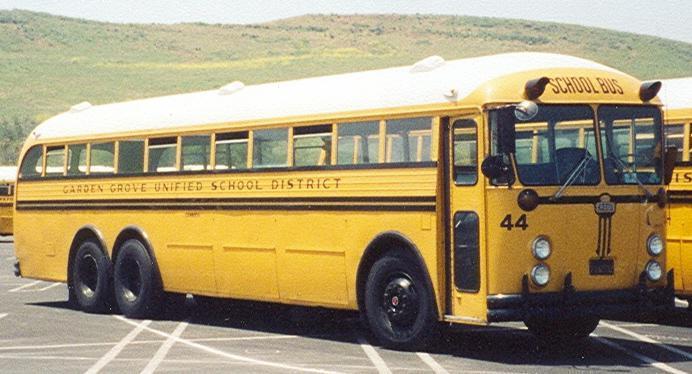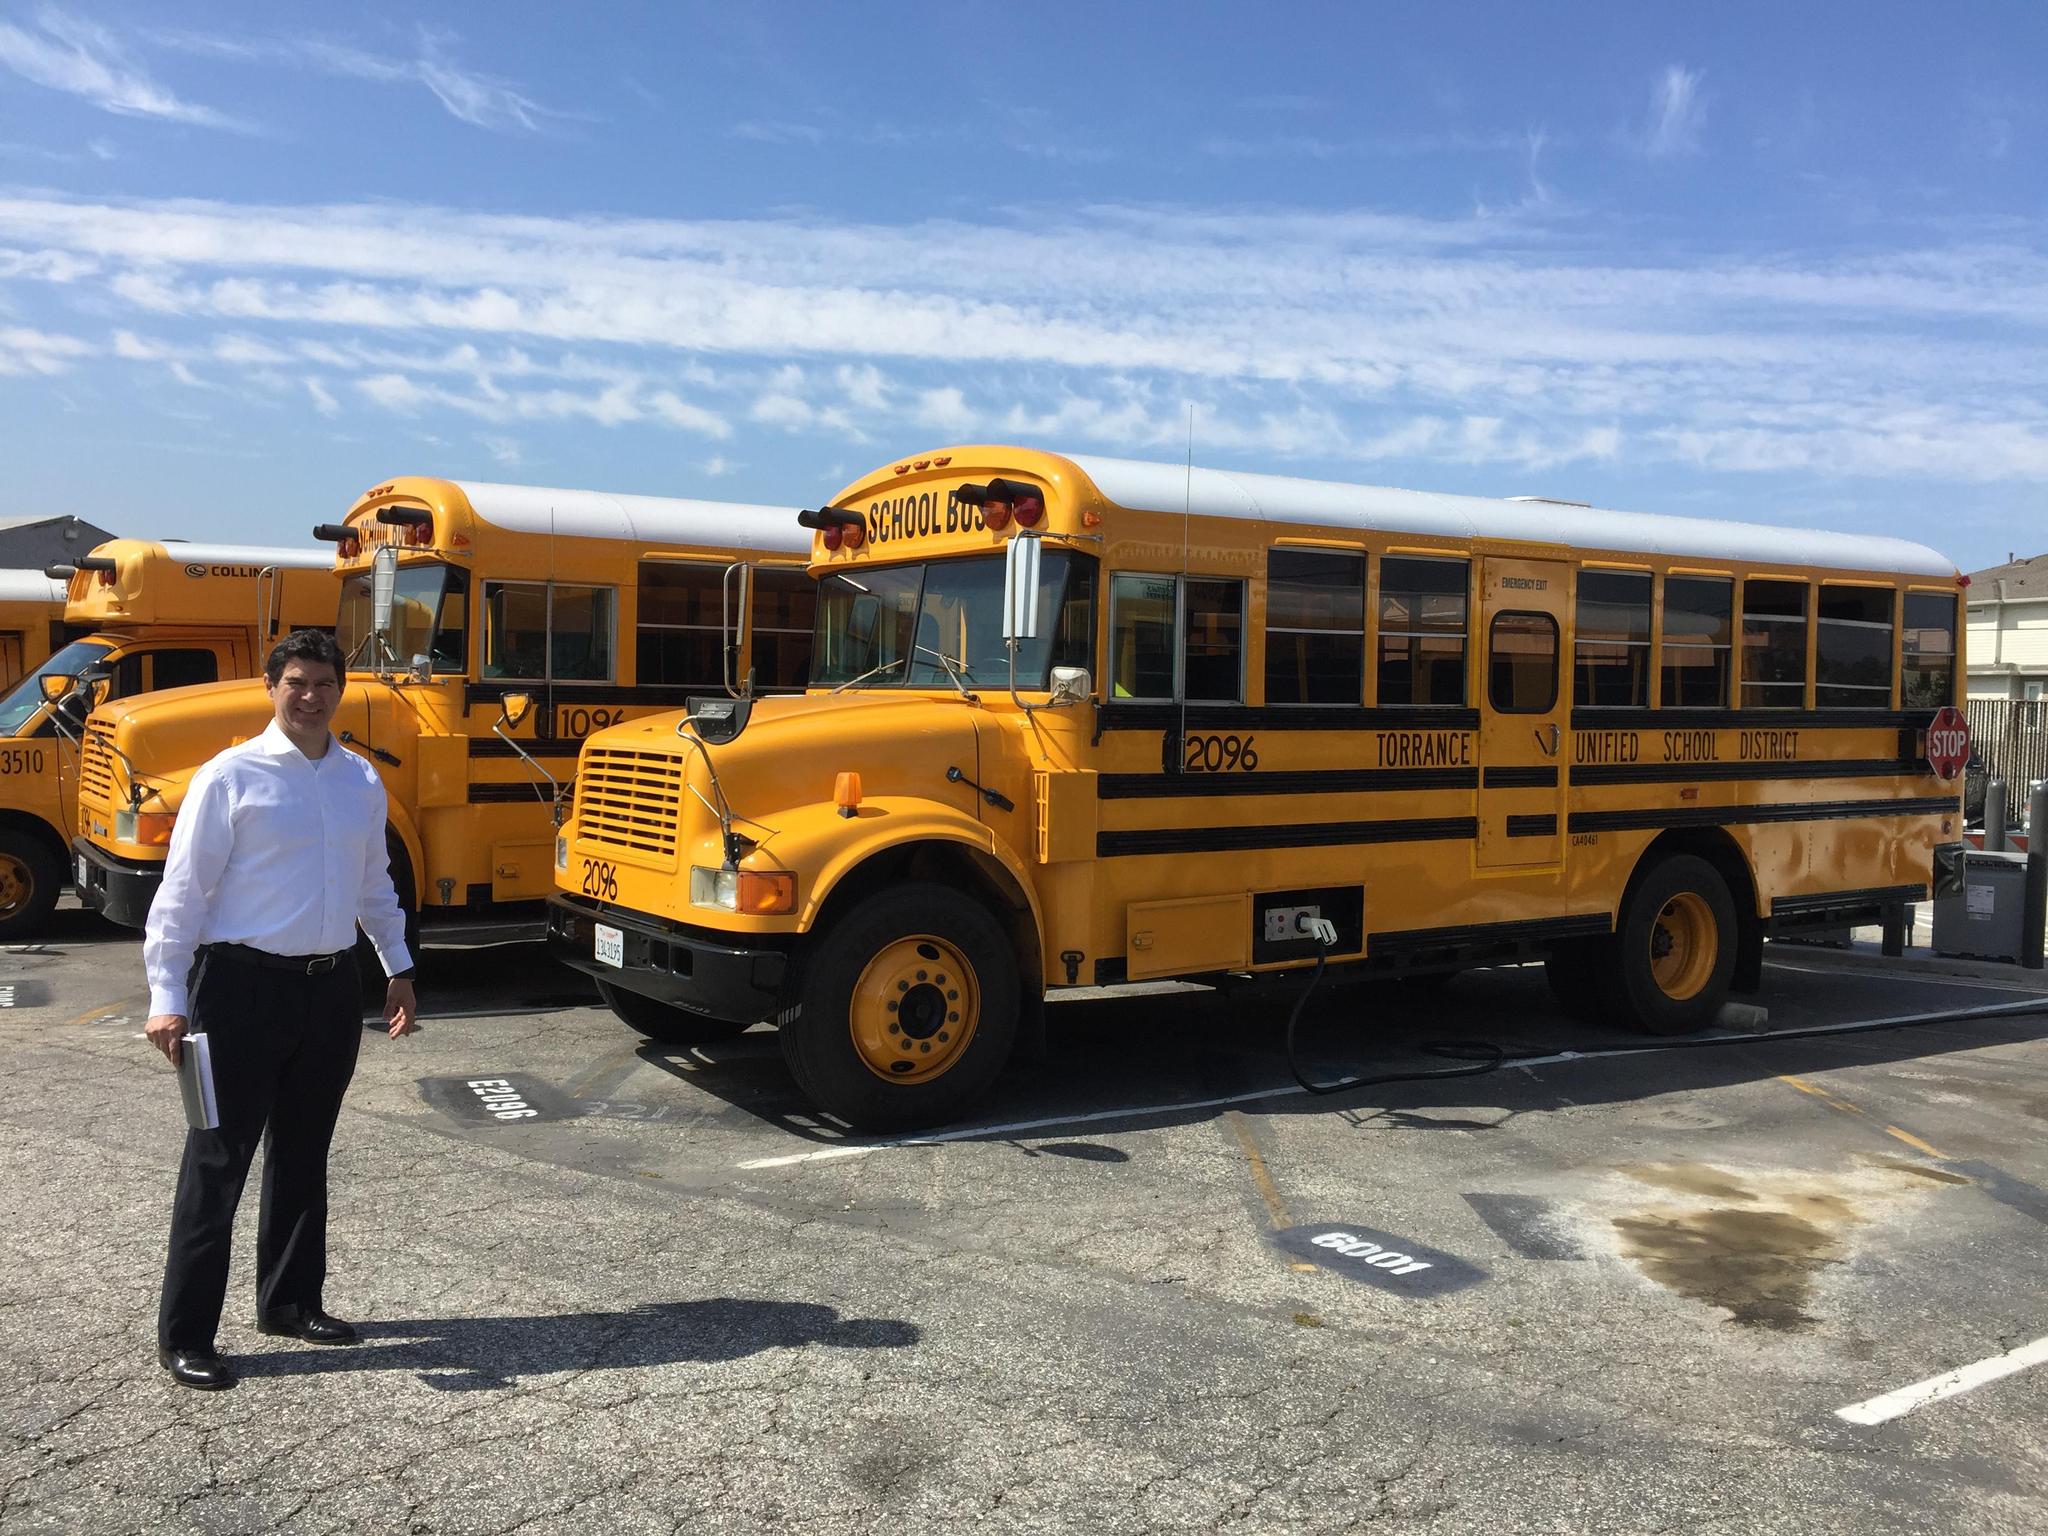The first image is the image on the left, the second image is the image on the right. Considering the images on both sides, is "In one image a series of school buses are parked in parallel rows." valid? Answer yes or no. Yes. The first image is the image on the left, the second image is the image on the right. Considering the images on both sides, is "The left image features one flat-fronted bus parked at an angle in a parking lot, and the right image features a row of parked buses forming a diagonal line." valid? Answer yes or no. Yes. 